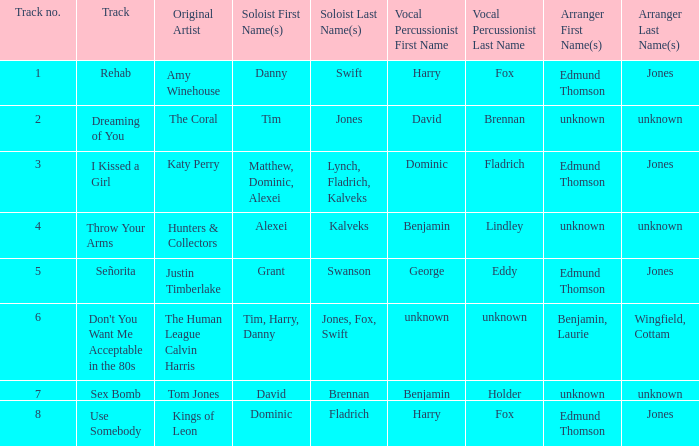Who is the vocal percussionist for Sex Bomb? Benjamin Holder. 